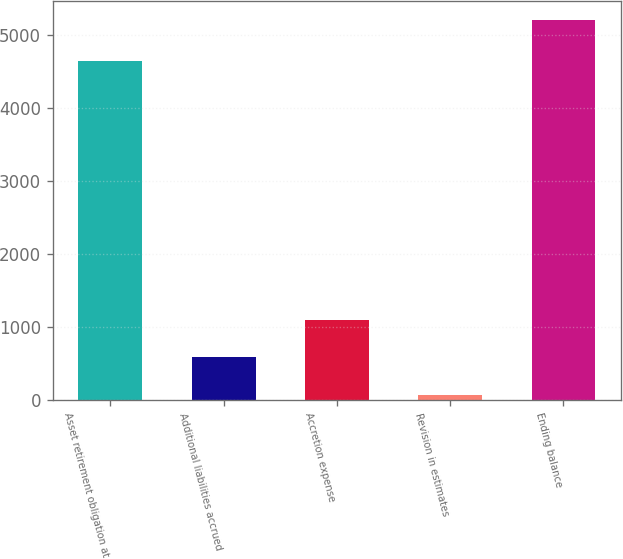Convert chart. <chart><loc_0><loc_0><loc_500><loc_500><bar_chart><fcel>Asset retirement obligation at<fcel>Additional liabilities accrued<fcel>Accretion expense<fcel>Revision in estimates<fcel>Ending balance<nl><fcel>4641<fcel>584.4<fcel>1098.8<fcel>70<fcel>5214<nl></chart> 